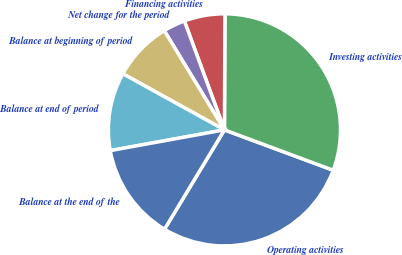Convert chart to OTSL. <chart><loc_0><loc_0><loc_500><loc_500><pie_chart><fcel>Operating activities<fcel>Investing activities<fcel>Financing activities<fcel>Net change for the period<fcel>Balance at beginning of period<fcel>Balance at end of period<fcel>Balance at the end of the<nl><fcel>27.98%<fcel>30.59%<fcel>5.68%<fcel>3.07%<fcel>8.29%<fcel>10.89%<fcel>13.5%<nl></chart> 